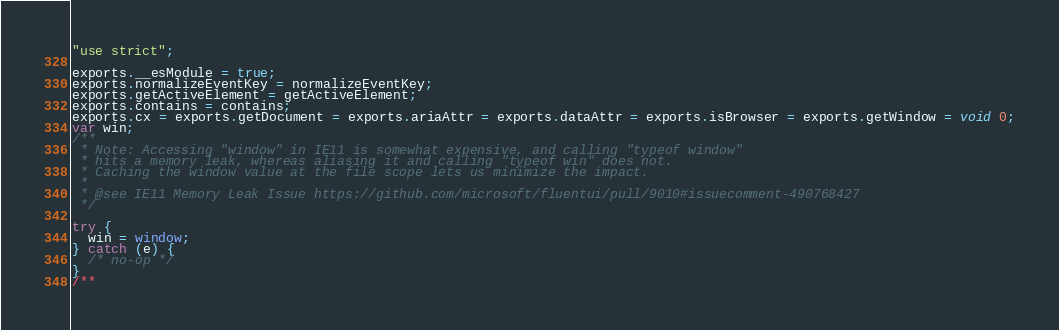<code> <loc_0><loc_0><loc_500><loc_500><_JavaScript_>"use strict";

exports.__esModule = true;
exports.normalizeEventKey = normalizeEventKey;
exports.getActiveElement = getActiveElement;
exports.contains = contains;
exports.cx = exports.getDocument = exports.ariaAttr = exports.dataAttr = exports.isBrowser = exports.getWindow = void 0;
var win;
/**
 * Note: Accessing "window" in IE11 is somewhat expensive, and calling "typeof window"
 * hits a memory leak, whereas aliasing it and calling "typeof win" does not.
 * Caching the window value at the file scope lets us minimize the impact.
 *
 * @see IE11 Memory Leak Issue https://github.com/microsoft/fluentui/pull/9010#issuecomment-490768427
 */

try {
  win = window;
} catch (e) {
  /* no-op */
}
/**</code> 